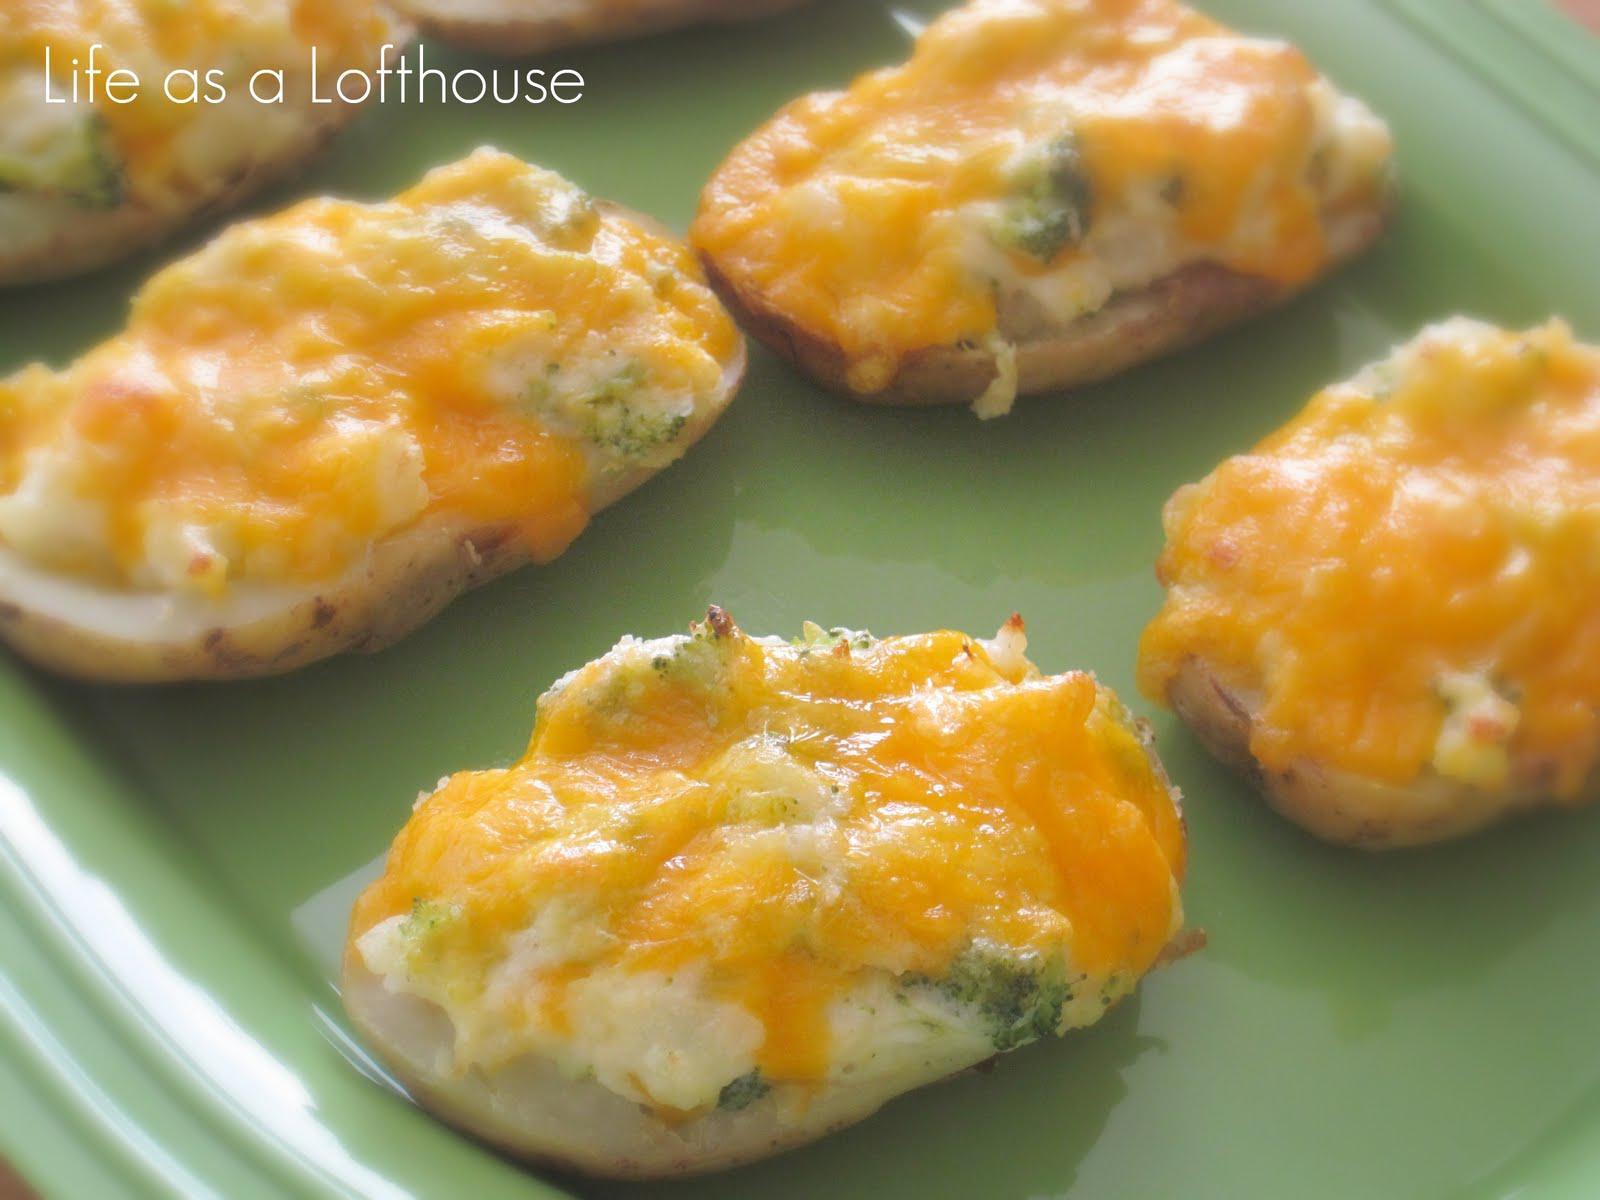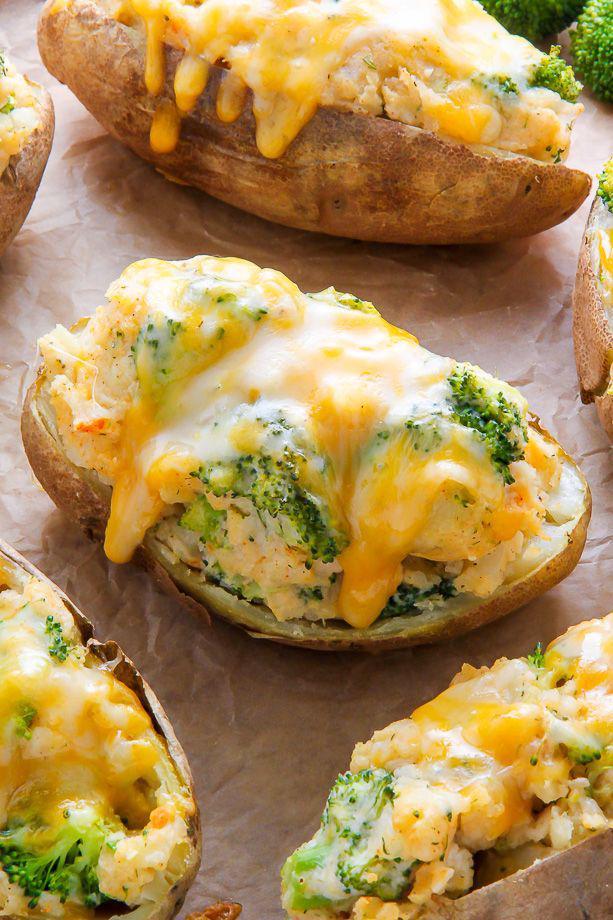The first image is the image on the left, the second image is the image on the right. Assess this claim about the two images: "Each image contains at least three baked stuffed potato.". Correct or not? Answer yes or no. Yes. The first image is the image on the left, the second image is the image on the right. For the images displayed, is the sentence "There is one piece of food on the dish on the right." factually correct? Answer yes or no. No. 